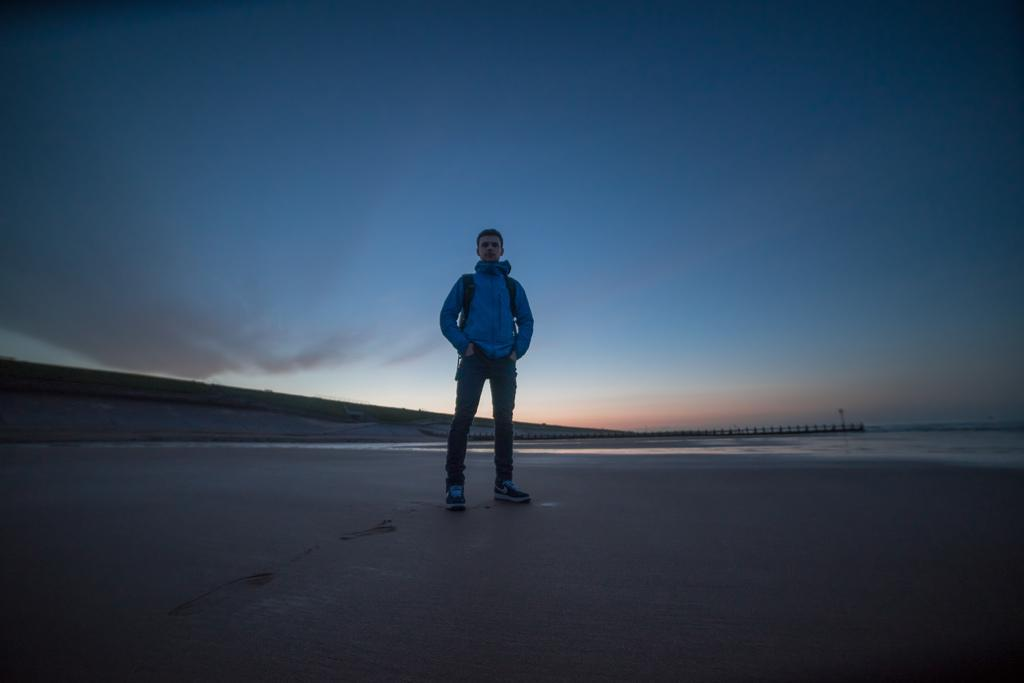What is the main subject of the image? There is a person standing in the image. What can be seen in the background of the image? There is an ocean in the background of the image. How would you describe the sky in the image? The sky is clear in the image. How many pigs are visible in the image? There are no pigs present in the image. What type of drink is being served in the image? There is no drink present in the image. 